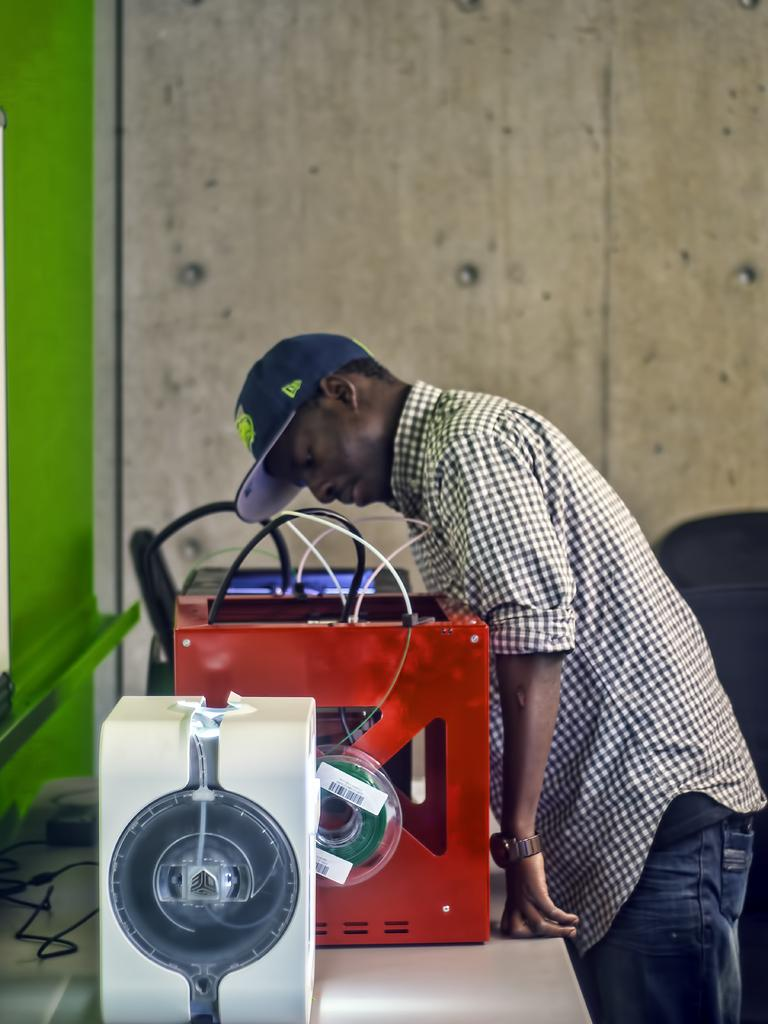What objects are on the table in the image? There are electronic boxes on the table in the image. Who is present in the image? There is a man standing in the image. What is the man wearing on his head? The man is wearing a cap on his head. What type of wall can be seen in the image? There is a wooden wall on the side of the image. What year is depicted on the oven in the image? There is no oven present in the image, so the year cannot be determined. 